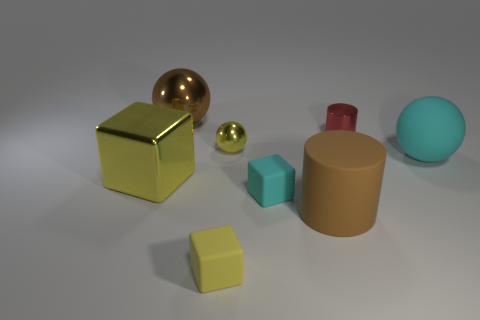Subtract all tiny cubes. How many cubes are left? 1 Subtract all cyan cylinders. How many yellow blocks are left? 2 Add 1 small cyan rubber blocks. How many objects exist? 9 Subtract all balls. How many objects are left? 5 Add 5 small brown metal cubes. How many small brown metal cubes exist? 5 Subtract 0 gray cylinders. How many objects are left? 8 Subtract all red blocks. Subtract all gray balls. How many blocks are left? 3 Subtract all big metal blocks. Subtract all rubber cubes. How many objects are left? 5 Add 4 small cyan matte blocks. How many small cyan matte blocks are left? 5 